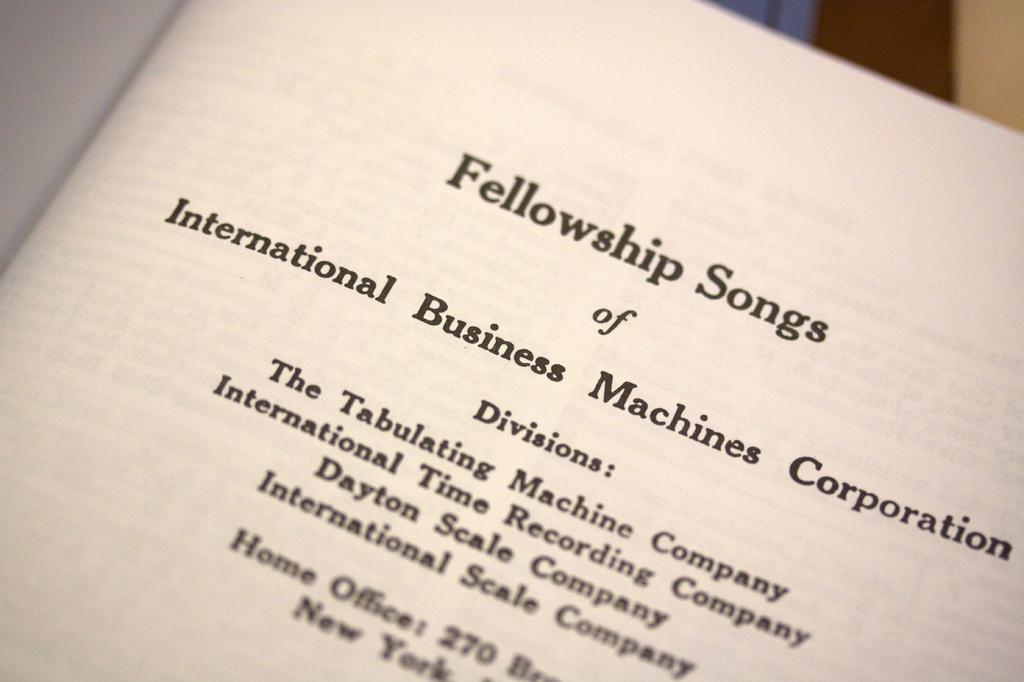<image>
Relay a brief, clear account of the picture shown. A book titled Fellowship Songs was written by The Tabulating Machine Company 